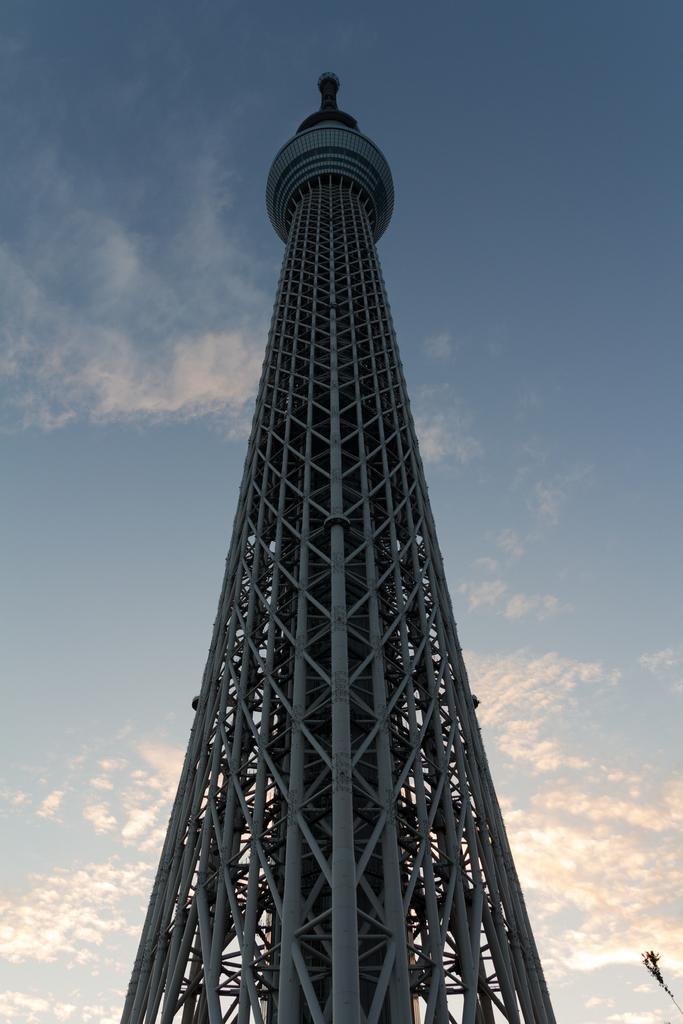What is the main structure in the image? There is a tall tower in the image. What can be seen in the background of the image? There is a sky visible in the background of the image. What is the condition of the sky in the image? There are clouds in the sky. Where is the hospital located in the image? There is no hospital present in the image. What type of battle is taking place in the image? There is no battle present in the image. 